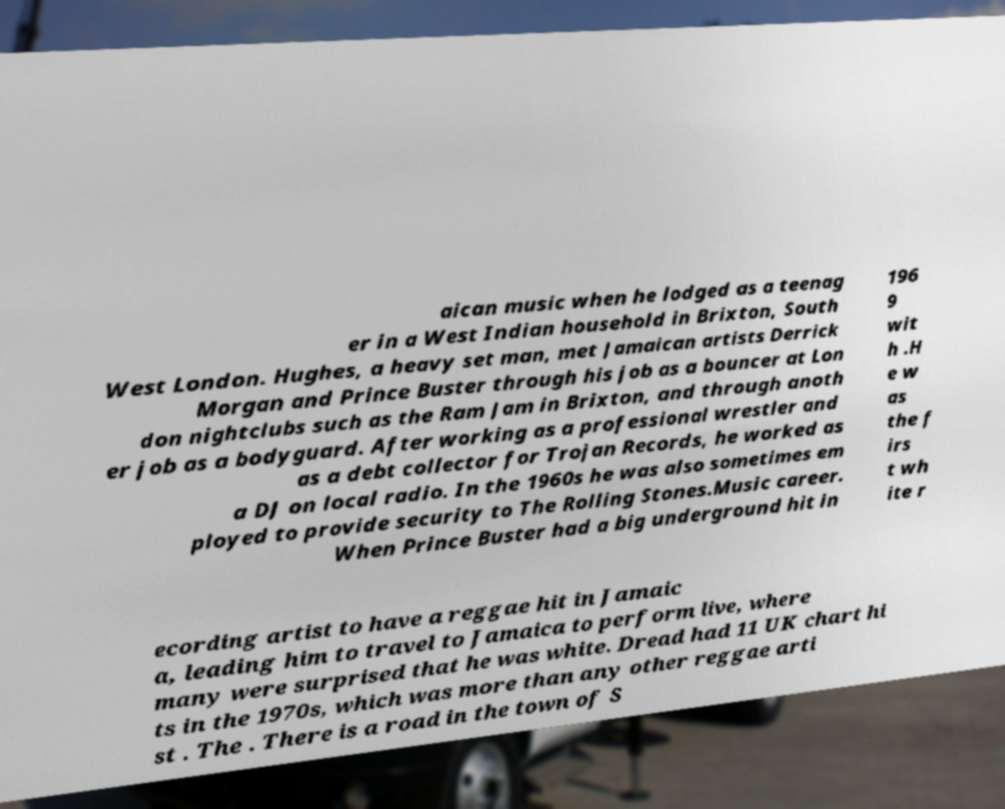For documentation purposes, I need the text within this image transcribed. Could you provide that? aican music when he lodged as a teenag er in a West Indian household in Brixton, South West London. Hughes, a heavy set man, met Jamaican artists Derrick Morgan and Prince Buster through his job as a bouncer at Lon don nightclubs such as the Ram Jam in Brixton, and through anoth er job as a bodyguard. After working as a professional wrestler and as a debt collector for Trojan Records, he worked as a DJ on local radio. In the 1960s he was also sometimes em ployed to provide security to The Rolling Stones.Music career. When Prince Buster had a big underground hit in 196 9 wit h .H e w as the f irs t wh ite r ecording artist to have a reggae hit in Jamaic a, leading him to travel to Jamaica to perform live, where many were surprised that he was white. Dread had 11 UK chart hi ts in the 1970s, which was more than any other reggae arti st . The . There is a road in the town of S 